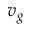<formula> <loc_0><loc_0><loc_500><loc_500>v _ { g }</formula> 